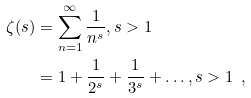<formula> <loc_0><loc_0><loc_500><loc_500>\zeta ( s ) & = \sum _ { n = 1 } ^ { \infty } \frac { 1 } { n ^ { s } } , s > 1 \\ & = 1 + \frac { 1 } { 2 ^ { s } } + \frac { 1 } { 3 ^ { s } } + \dots , s > 1 \, \ ,</formula> 